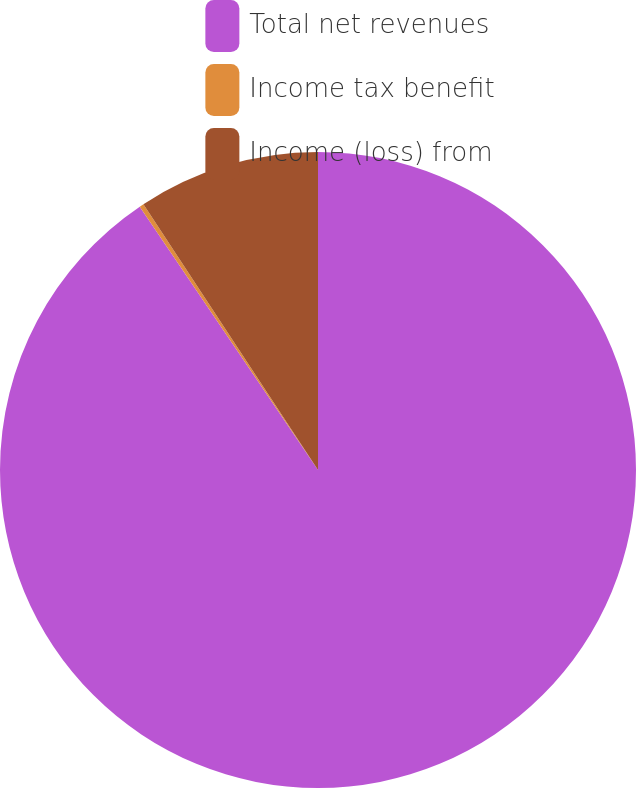Convert chart. <chart><loc_0><loc_0><loc_500><loc_500><pie_chart><fcel>Total net revenues<fcel>Income tax benefit<fcel>Income (loss) from<nl><fcel>90.53%<fcel>0.22%<fcel>9.25%<nl></chart> 